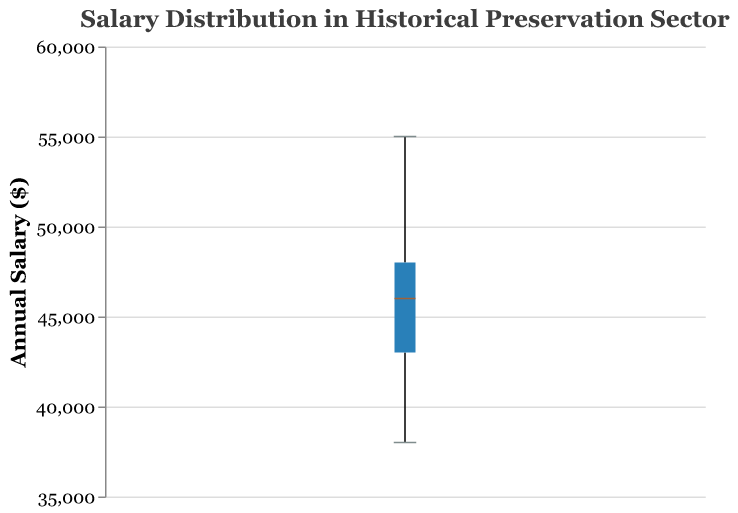What is the title of the figure? The title is located at the top of the figure and typically provides a concise summary of the visualized data. It helps viewers quickly understand what the plot is about.
Answer: Salary Distribution in Historical Preservation Sector What is the range of the salaries shown in the box plot? The range is determined by the minimum and maximum data points displayed on the box plot. The minimum annual salary is $38,000, and the maximum is $55,000.
Answer: $38,000 to $55,000 What is the median salary in the data? The median salary is represented by the line inside the box of the box plot. The median in this plot is $45,000.
Answer: $45,000 Which job title has the highest annual salary? By examining the list of data points provided, we identify the highest salary, which is $55,000 for the Heritage Planner.
Answer: Heritage Planner Compare the median salary with the salary of a Historical Consultant. Is it higher or lower? The median salary is $45,000, while the salary of a Historical Consultant is $52,000. Therefore, the Historical Consultant’s salary is higher than the median.
Answer: Higher How many job titles have salaries greater than the median? To find this, we count the number of salaries that exceed the median value of $45,000. These are: $46,000, $48,000, $47,000, $52,000, and $55,000, yielding 5 job titles.
Answer: 5 What is the interquartile range (IQR) of the salaries? The IQR is the difference between the third quartile (75th percentile) and the first quartile (25th percentile). From the box plot, the first quartile is $42,250, and the third quartile is $48,000. The IQR is $48,000 - $42,250.
Answer: $5,750 Which job title has the lowest annual salary, and how does it compare to the median salary? The Preservation Specialist has the lowest salary at $38,000. The median salary is $45,000. Therefore, the lowest salary is $7,000 less than the median.
Answer: Preservation Specialist, $7,000 less Does the box plot indicate any potential outliers? Outliers would typically be shown as individual points outside the "whiskers" of the box plot. Since there are no such points in the figure, there are no outliers indicated.
Answer: No What is the range between the highest and lowest salaries? The range is calculated by subtracting the lowest salary from the highest salary: $55,000 - $38,000.
Answer: $17,000 